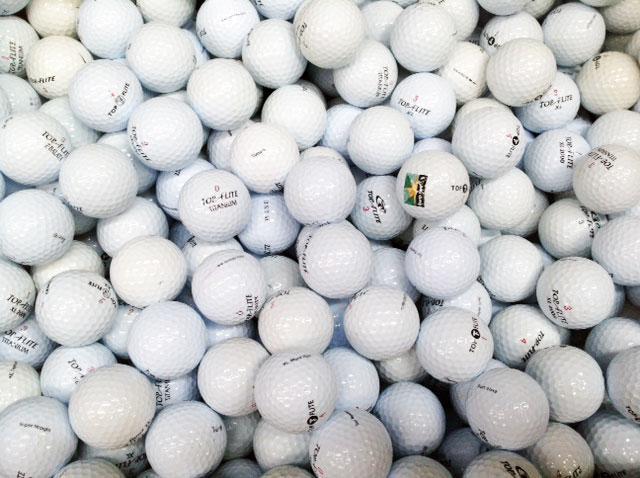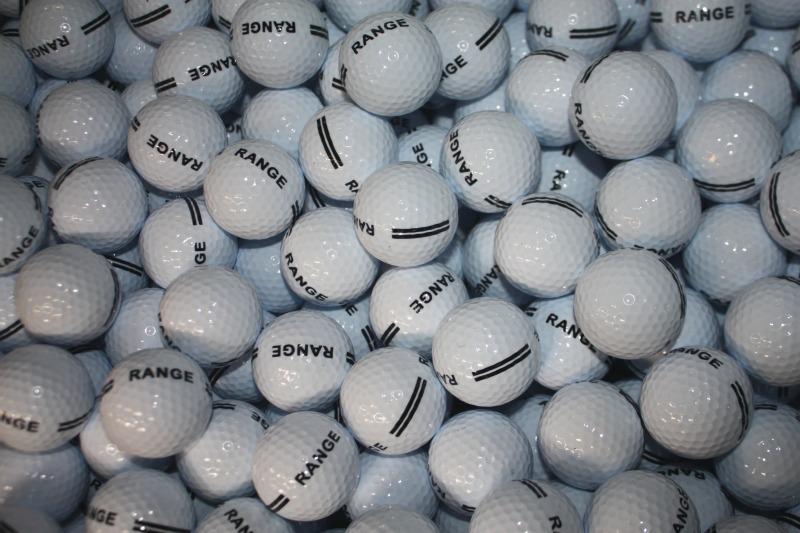The first image is the image on the left, the second image is the image on the right. Analyze the images presented: Is the assertion "None of the balls are in shadow in one of the images." valid? Answer yes or no. No. 